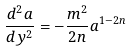<formula> <loc_0><loc_0><loc_500><loc_500>\frac { d ^ { 2 } a } { d y ^ { 2 } } = - \frac { m ^ { 2 } } { 2 n } a ^ { 1 - 2 n }</formula> 